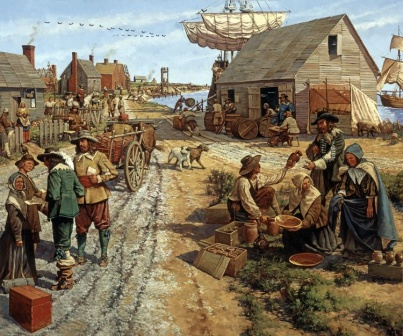Who do you think the central figures in the image might be in terms of their roles or professions? The central figures in the image appear to be a diverse group involved in various roles typical of a colonial-era village. The man with the basket of fruit on his head could be a vendor or a common villager returning from the market. The two women accompanying him might be shoppers or fellow vendors. The individuals near the cart on the right side could be tradespeople or farmers transporting goods, reflecting the importance of trade and agriculture during that period. The presence of a large ship in the background further suggests the involvement of maritime trade, indicating that some villagers might have roles related to the harbor, such as sailors, merchants, or dockworkers. 